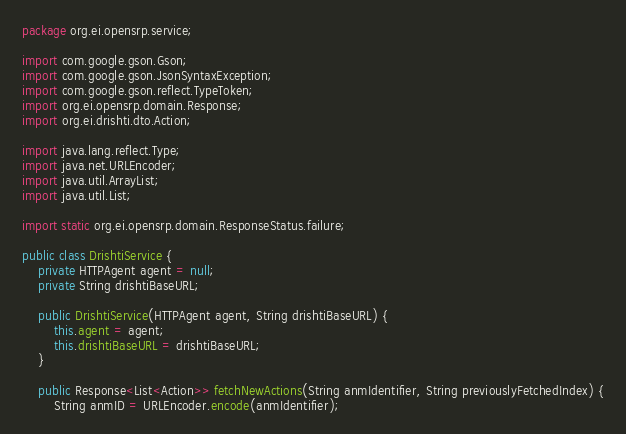Convert code to text. <code><loc_0><loc_0><loc_500><loc_500><_Java_>package org.ei.opensrp.service;

import com.google.gson.Gson;
import com.google.gson.JsonSyntaxException;
import com.google.gson.reflect.TypeToken;
import org.ei.opensrp.domain.Response;
import org.ei.drishti.dto.Action;

import java.lang.reflect.Type;
import java.net.URLEncoder;
import java.util.ArrayList;
import java.util.List;

import static org.ei.opensrp.domain.ResponseStatus.failure;

public class DrishtiService {
    private HTTPAgent agent = null;
    private String drishtiBaseURL;

    public DrishtiService(HTTPAgent agent, String drishtiBaseURL) {
        this.agent = agent;
        this.drishtiBaseURL = drishtiBaseURL;
    }

    public Response<List<Action>> fetchNewActions(String anmIdentifier, String previouslyFetchedIndex) {
        String anmID = URLEncoder.encode(anmIdentifier);</code> 